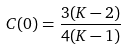<formula> <loc_0><loc_0><loc_500><loc_500>C ( 0 ) = \frac { 3 ( K - 2 ) } { 4 ( K - 1 ) }</formula> 